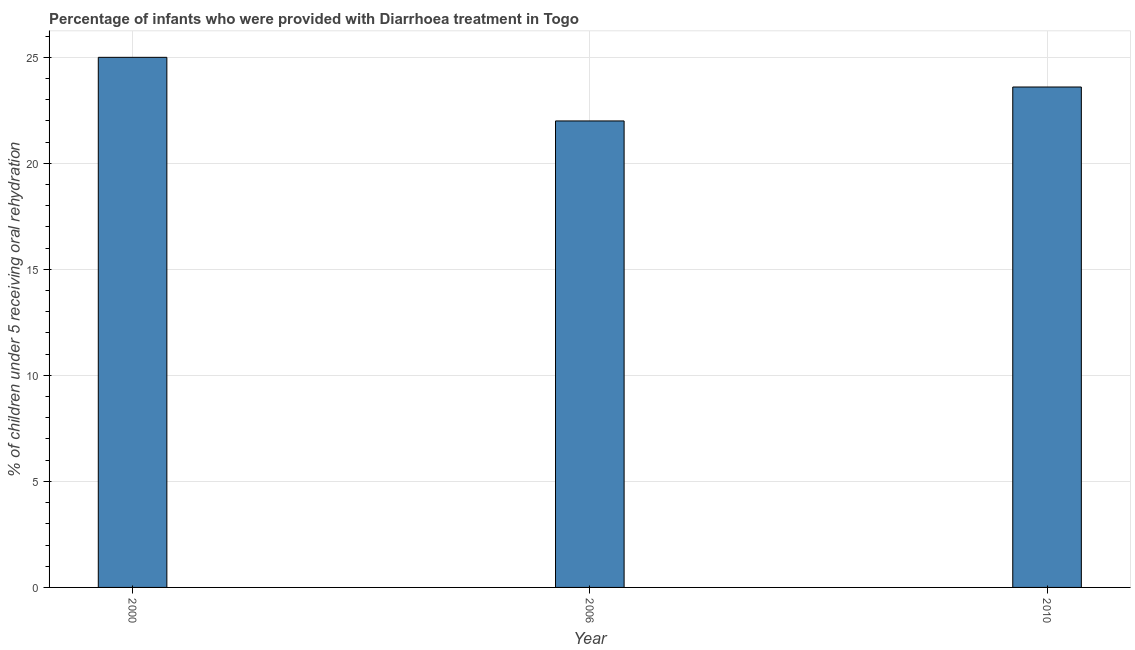What is the title of the graph?
Give a very brief answer. Percentage of infants who were provided with Diarrhoea treatment in Togo. What is the label or title of the X-axis?
Give a very brief answer. Year. What is the label or title of the Y-axis?
Offer a very short reply. % of children under 5 receiving oral rehydration. What is the percentage of children who were provided with treatment diarrhoea in 2010?
Your answer should be very brief. 23.6. Across all years, what is the maximum percentage of children who were provided with treatment diarrhoea?
Keep it short and to the point. 25. Across all years, what is the minimum percentage of children who were provided with treatment diarrhoea?
Your answer should be very brief. 22. In which year was the percentage of children who were provided with treatment diarrhoea maximum?
Your response must be concise. 2000. In which year was the percentage of children who were provided with treatment diarrhoea minimum?
Provide a short and direct response. 2006. What is the sum of the percentage of children who were provided with treatment diarrhoea?
Offer a terse response. 70.6. What is the average percentage of children who were provided with treatment diarrhoea per year?
Offer a terse response. 23.53. What is the median percentage of children who were provided with treatment diarrhoea?
Offer a terse response. 23.6. In how many years, is the percentage of children who were provided with treatment diarrhoea greater than 7 %?
Offer a terse response. 3. Do a majority of the years between 2000 and 2006 (inclusive) have percentage of children who were provided with treatment diarrhoea greater than 8 %?
Your answer should be very brief. Yes. What is the ratio of the percentage of children who were provided with treatment diarrhoea in 2006 to that in 2010?
Make the answer very short. 0.93. Is the percentage of children who were provided with treatment diarrhoea in 2006 less than that in 2010?
Your response must be concise. Yes. Is the difference between the percentage of children who were provided with treatment diarrhoea in 2000 and 2010 greater than the difference between any two years?
Provide a short and direct response. No. What is the difference between the highest and the second highest percentage of children who were provided with treatment diarrhoea?
Your answer should be compact. 1.4. How many bars are there?
Offer a very short reply. 3. How many years are there in the graph?
Offer a terse response. 3. What is the % of children under 5 receiving oral rehydration in 2006?
Give a very brief answer. 22. What is the % of children under 5 receiving oral rehydration of 2010?
Offer a terse response. 23.6. What is the difference between the % of children under 5 receiving oral rehydration in 2000 and 2006?
Keep it short and to the point. 3. What is the difference between the % of children under 5 receiving oral rehydration in 2000 and 2010?
Make the answer very short. 1.4. What is the ratio of the % of children under 5 receiving oral rehydration in 2000 to that in 2006?
Your answer should be very brief. 1.14. What is the ratio of the % of children under 5 receiving oral rehydration in 2000 to that in 2010?
Offer a very short reply. 1.06. What is the ratio of the % of children under 5 receiving oral rehydration in 2006 to that in 2010?
Your answer should be compact. 0.93. 